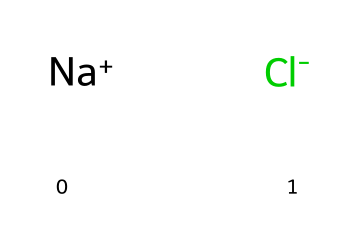What is the overall charge of this compound? This compound consists of a sodium ion (Na+) which has a positive charge and a chloride ion (Cl-) which has a negative charge. The overall charge is the sum of these charges, resulting in a neutral compound because +1 and -1 cancel each other out.
Answer: neutral How many total ions are present in the formula represented? The formula indicates one sodium ion (Na+) and one chloride ion (Cl-), making a total of two ions in this compound when counting each individual ion.
Answer: two What type of chemical bond is formed in sodium chloride? Sodium chloride is held together by ionic bonds, which occur between positively charged ions (like Na+) and negatively charged ions (like Cl-). These bonds form due to the attraction between opposite charges.
Answer: ionic What are the constituent elements of sodium chloride? The compound is made up of two elements: sodium (Na) and chlorine (Cl). Each plays a crucial role, as sodium is a metal and chlorine is a non-metal, together forming the ionic bond in the compound.
Answer: sodium and chlorine Which ion is responsible for the salty taste of table salt? The chloride ion (Cl-) is commonly recognized to contribute to the distinct salty flavor of table salt. It is important in biological systems and adds flavor enhancement in food.
Answer: chloride What happens to sodium and chloride ions in solution? When sodium chloride is dissolved in water, the Na+ and Cl- ions separate and disperse throughout the solution. This dissociation allows them to interact with water molecules, which is vital for various chemical processes.
Answer: they dissociate 